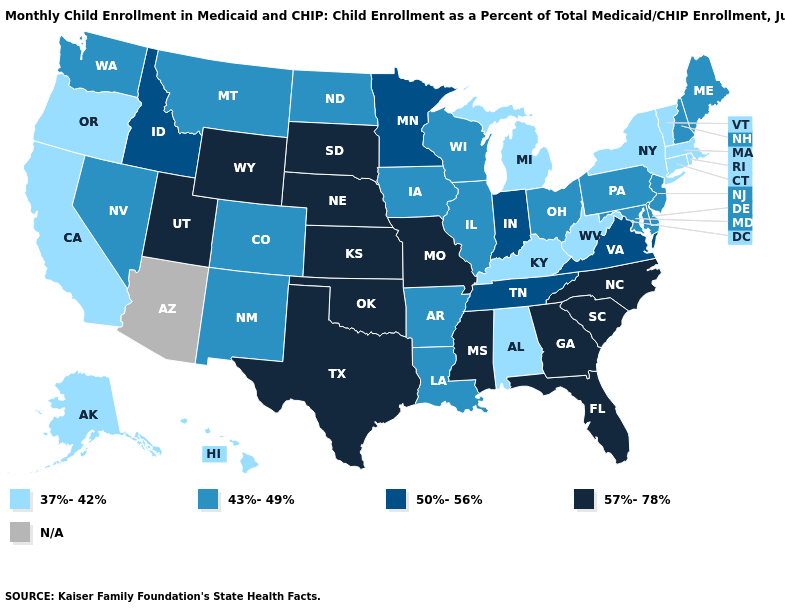How many symbols are there in the legend?
Concise answer only. 5. What is the lowest value in the USA?
Quick response, please. 37%-42%. Name the states that have a value in the range N/A?
Write a very short answer. Arizona. What is the lowest value in the West?
Be succinct. 37%-42%. What is the value of Nebraska?
Be succinct. 57%-78%. Name the states that have a value in the range 37%-42%?
Write a very short answer. Alabama, Alaska, California, Connecticut, Hawaii, Kentucky, Massachusetts, Michigan, New York, Oregon, Rhode Island, Vermont, West Virginia. What is the highest value in states that border Connecticut?
Quick response, please. 37%-42%. Name the states that have a value in the range 43%-49%?
Be succinct. Arkansas, Colorado, Delaware, Illinois, Iowa, Louisiana, Maine, Maryland, Montana, Nevada, New Hampshire, New Jersey, New Mexico, North Dakota, Ohio, Pennsylvania, Washington, Wisconsin. Is the legend a continuous bar?
Be succinct. No. What is the value of Hawaii?
Quick response, please. 37%-42%. Does the map have missing data?
Quick response, please. Yes. Name the states that have a value in the range 37%-42%?
Quick response, please. Alabama, Alaska, California, Connecticut, Hawaii, Kentucky, Massachusetts, Michigan, New York, Oregon, Rhode Island, Vermont, West Virginia. Is the legend a continuous bar?
Be succinct. No. Among the states that border South Carolina , which have the lowest value?
Short answer required. Georgia, North Carolina. What is the lowest value in states that border Wyoming?
Be succinct. 43%-49%. 